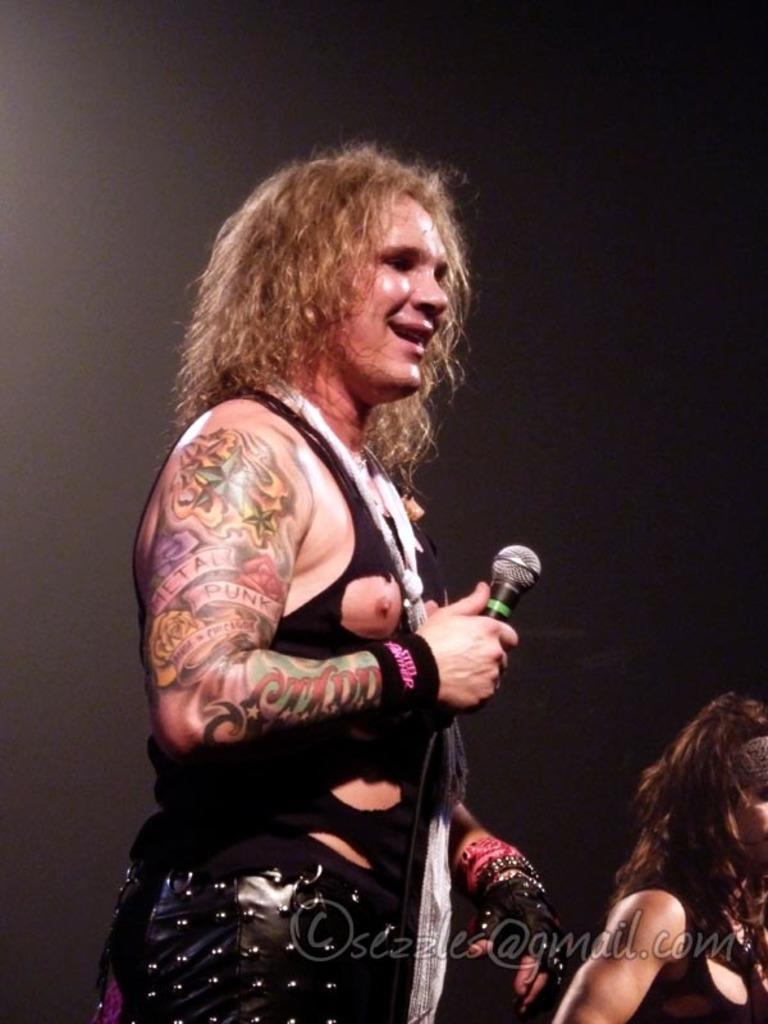What is the main subject of the image? There is a person standing in the middle of the image. What is the person in the middle holding? The person in the middle is holding a microphone. Are there any other people visible in the image? Yes, there is another person standing in the bottom right corner of the image. How does the earthquake affect the person holding the microphone in the image? There is no earthquake present in the image, so its effects cannot be determined. 